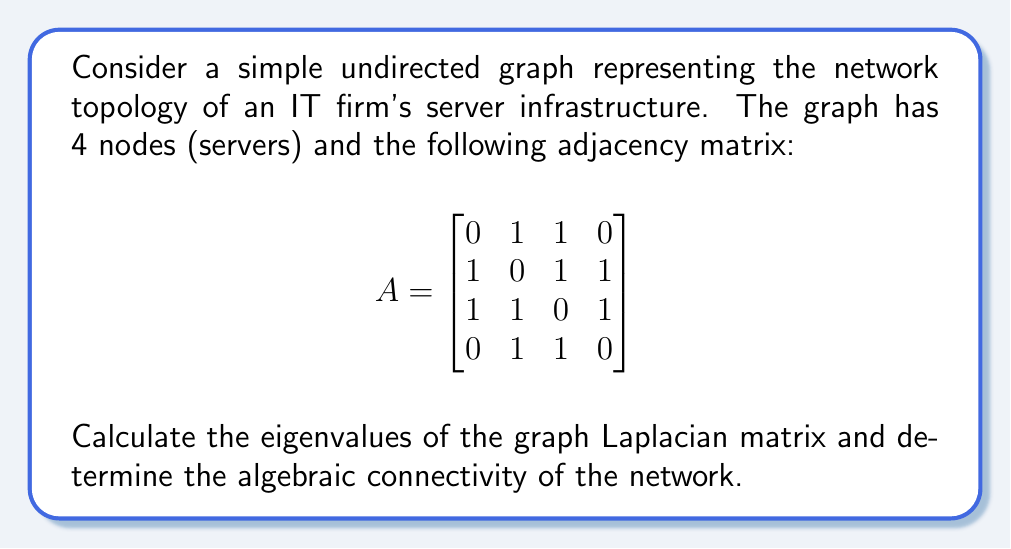Could you help me with this problem? Step 1: Calculate the degree matrix D.
The degree of each node is the sum of its row in the adjacency matrix:
$$D = \begin{bmatrix}
2 & 0 & 0 & 0 \\
0 & 3 & 0 & 0 \\
0 & 0 & 3 & 0 \\
0 & 0 & 0 & 2
\end{bmatrix}$$

Step 2: Calculate the Laplacian matrix L = D - A.
$$L = D - A = \begin{bmatrix}
2 & -1 & -1 & 0 \\
-1 & 3 & -1 & -1 \\
-1 & -1 & 3 & -1 \\
0 & -1 & -1 & 2
\end{bmatrix}$$

Step 3: Calculate the characteristic polynomial of L.
$$\det(L - \lambda I) = \lambda^4 - 10\lambda^3 + 31\lambda^2 - 30\lambda$$

Step 4: Find the roots of the characteristic polynomial.
The roots are the eigenvalues of L: $\lambda_1 = 0$, $\lambda_2 = 1$, $\lambda_3 = 3$, $\lambda_4 = 6$

Step 5: Determine the algebraic connectivity.
The algebraic connectivity is the second smallest eigenvalue of L, which is $\lambda_2 = 1$.
Answer: Eigenvalues: 0, 1, 3, 6; Algebraic connectivity: 1 